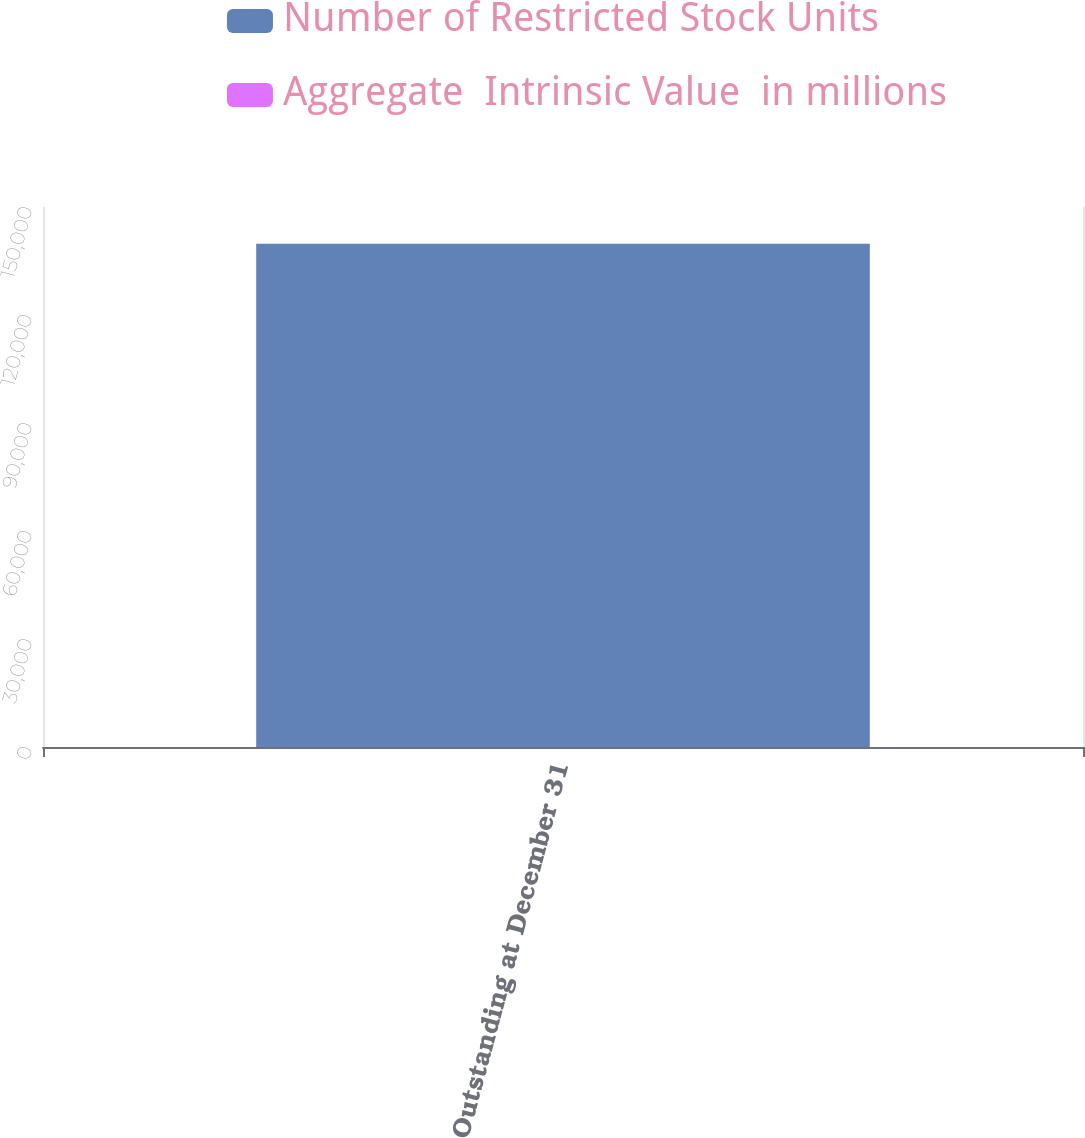Convert chart. <chart><loc_0><loc_0><loc_500><loc_500><stacked_bar_chart><ecel><fcel>Outstanding at December 31<nl><fcel>Number of Restricted Stock Units<fcel>139774<nl><fcel>Aggregate  Intrinsic Value  in millions<fcel>20.6<nl></chart> 